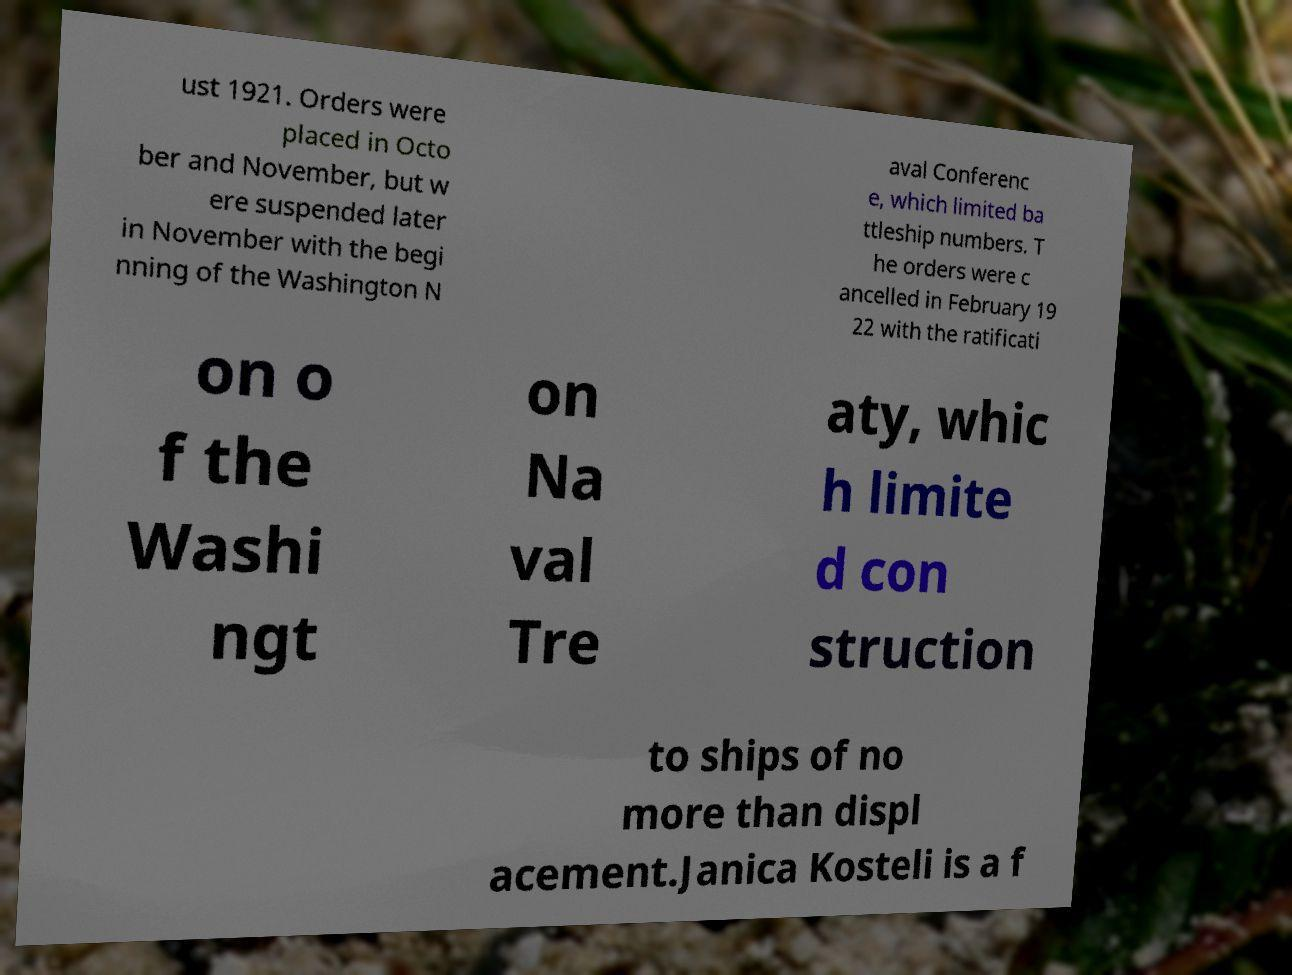Please read and relay the text visible in this image. What does it say? ust 1921. Orders were placed in Octo ber and November, but w ere suspended later in November with the begi nning of the Washington N aval Conferenc e, which limited ba ttleship numbers. T he orders were c ancelled in February 19 22 with the ratificati on o f the Washi ngt on Na val Tre aty, whic h limite d con struction to ships of no more than displ acement.Janica Kosteli is a f 